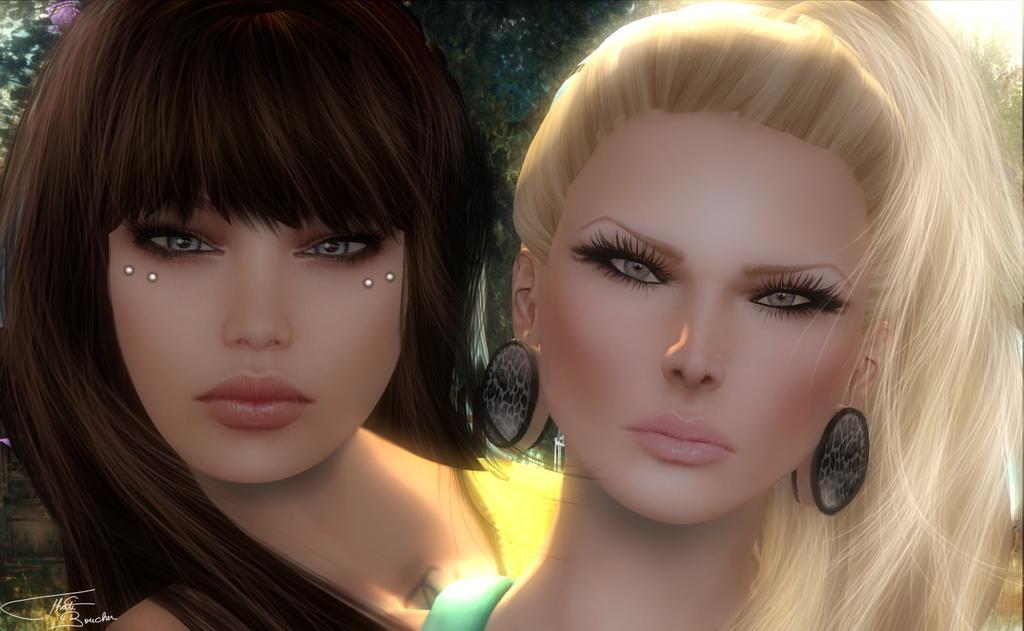Could you give a brief overview of what you see in this image? In this picture I can see the animated image. In that I can see two women faces. In the background I can see the trees. In the top right corner I can see the sky. In the bottom left corner there is a watermark. 